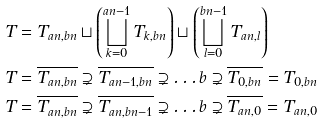<formula> <loc_0><loc_0><loc_500><loc_500>T & = T _ { a n , b n } \sqcup \left ( \bigsqcup _ { k = 0 } ^ { a n - 1 } T _ { k , b n } \right ) \sqcup \left ( \bigsqcup _ { l = 0 } ^ { b n - 1 } T _ { a n , l } \right ) \\ T & = \overline { T _ { a n , b n } } \supsetneq \overline { T _ { a n - 1 , b n } } \supsetneq \dots b \supsetneq \overline { T _ { 0 , b n } } = T _ { 0 , b n } \\ T & = \overline { T _ { a n , b n } } \supsetneq \overline { T _ { a n , b n - 1 } } \supsetneq \dots b \supsetneq \overline { T _ { a n , 0 } } = T _ { a n , 0 }</formula> 